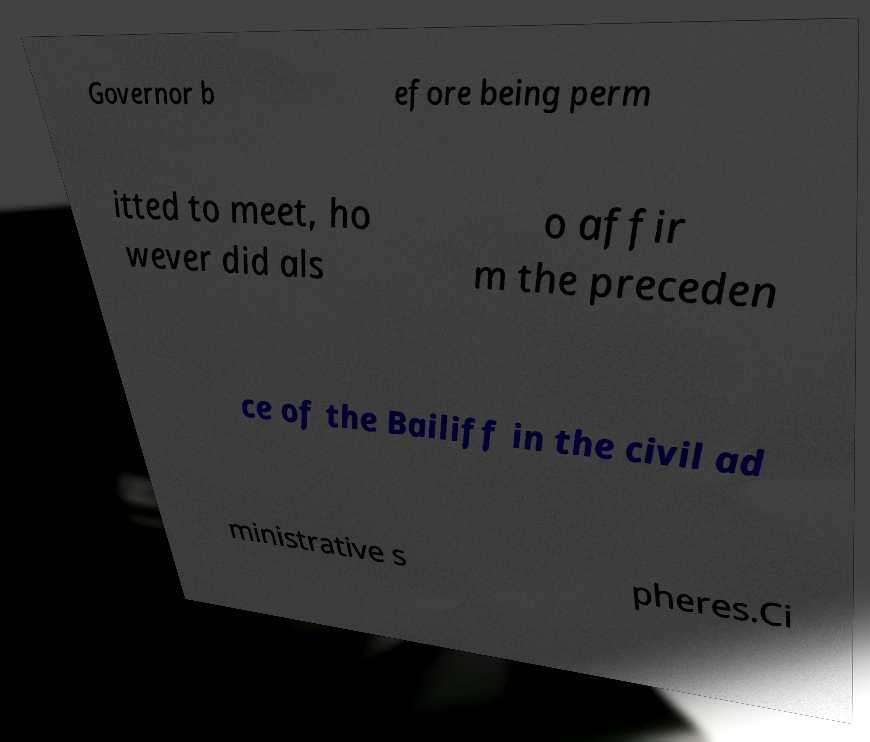What messages or text are displayed in this image? I need them in a readable, typed format. Governor b efore being perm itted to meet, ho wever did als o affir m the preceden ce of the Bailiff in the civil ad ministrative s pheres.Ci 